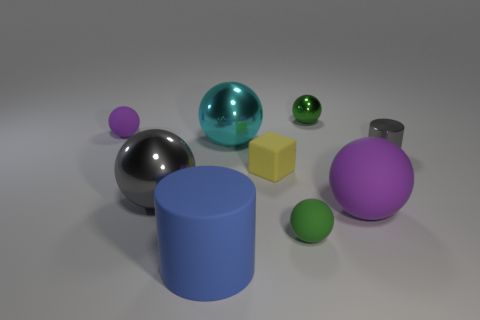How many other things are the same size as the yellow cube?
Ensure brevity in your answer.  4. What number of metal cylinders are there?
Ensure brevity in your answer.  1. Is there any other thing that has the same shape as the small yellow object?
Offer a terse response. No. Is the purple sphere that is in front of the small yellow thing made of the same material as the cylinder that is to the left of the small cylinder?
Your answer should be very brief. Yes. What is the big purple thing made of?
Your answer should be compact. Rubber. How many large balls are made of the same material as the small cube?
Provide a short and direct response. 1. How many metal things are gray things or large cyan cylinders?
Your response must be concise. 2. Is the shape of the big cyan thing that is left of the tiny yellow rubber thing the same as the big metallic thing in front of the yellow rubber cube?
Provide a succinct answer. Yes. There is a tiny ball that is both right of the large gray metallic ball and behind the small yellow rubber cube; what color is it?
Your answer should be compact. Green. Do the purple thing that is in front of the shiny cylinder and the metal sphere left of the cyan thing have the same size?
Your response must be concise. Yes. 